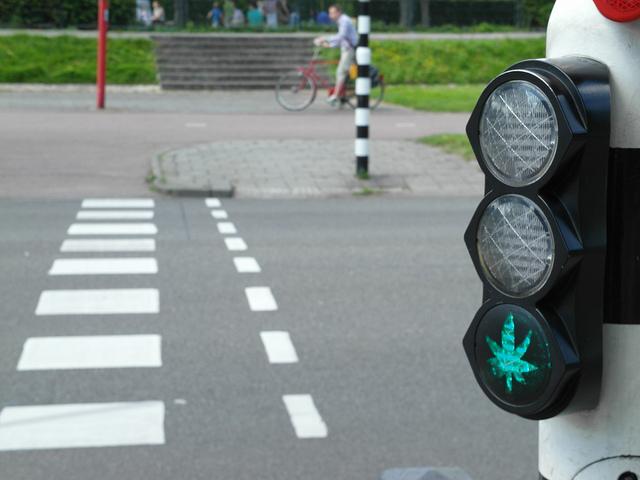Is the light red?
Give a very brief answer. No. What color is the light?
Concise answer only. Green. What symbol is on the green light?
Be succinct. Leaf. Is the green light lucky?
Answer briefly. No. What does the green lit symbol mean?
Keep it brief. Marijuana. 